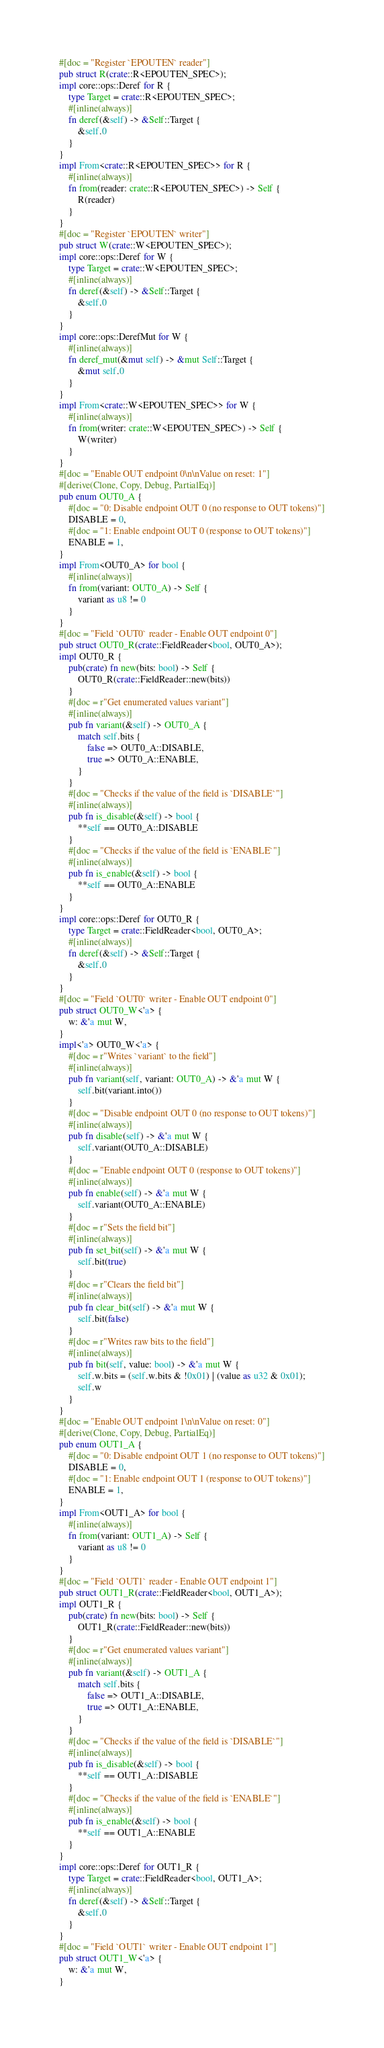Convert code to text. <code><loc_0><loc_0><loc_500><loc_500><_Rust_>#[doc = "Register `EPOUTEN` reader"]
pub struct R(crate::R<EPOUTEN_SPEC>);
impl core::ops::Deref for R {
    type Target = crate::R<EPOUTEN_SPEC>;
    #[inline(always)]
    fn deref(&self) -> &Self::Target {
        &self.0
    }
}
impl From<crate::R<EPOUTEN_SPEC>> for R {
    #[inline(always)]
    fn from(reader: crate::R<EPOUTEN_SPEC>) -> Self {
        R(reader)
    }
}
#[doc = "Register `EPOUTEN` writer"]
pub struct W(crate::W<EPOUTEN_SPEC>);
impl core::ops::Deref for W {
    type Target = crate::W<EPOUTEN_SPEC>;
    #[inline(always)]
    fn deref(&self) -> &Self::Target {
        &self.0
    }
}
impl core::ops::DerefMut for W {
    #[inline(always)]
    fn deref_mut(&mut self) -> &mut Self::Target {
        &mut self.0
    }
}
impl From<crate::W<EPOUTEN_SPEC>> for W {
    #[inline(always)]
    fn from(writer: crate::W<EPOUTEN_SPEC>) -> Self {
        W(writer)
    }
}
#[doc = "Enable OUT endpoint 0\n\nValue on reset: 1"]
#[derive(Clone, Copy, Debug, PartialEq)]
pub enum OUT0_A {
    #[doc = "0: Disable endpoint OUT 0 (no response to OUT tokens)"]
    DISABLE = 0,
    #[doc = "1: Enable endpoint OUT 0 (response to OUT tokens)"]
    ENABLE = 1,
}
impl From<OUT0_A> for bool {
    #[inline(always)]
    fn from(variant: OUT0_A) -> Self {
        variant as u8 != 0
    }
}
#[doc = "Field `OUT0` reader - Enable OUT endpoint 0"]
pub struct OUT0_R(crate::FieldReader<bool, OUT0_A>);
impl OUT0_R {
    pub(crate) fn new(bits: bool) -> Self {
        OUT0_R(crate::FieldReader::new(bits))
    }
    #[doc = r"Get enumerated values variant"]
    #[inline(always)]
    pub fn variant(&self) -> OUT0_A {
        match self.bits {
            false => OUT0_A::DISABLE,
            true => OUT0_A::ENABLE,
        }
    }
    #[doc = "Checks if the value of the field is `DISABLE`"]
    #[inline(always)]
    pub fn is_disable(&self) -> bool {
        **self == OUT0_A::DISABLE
    }
    #[doc = "Checks if the value of the field is `ENABLE`"]
    #[inline(always)]
    pub fn is_enable(&self) -> bool {
        **self == OUT0_A::ENABLE
    }
}
impl core::ops::Deref for OUT0_R {
    type Target = crate::FieldReader<bool, OUT0_A>;
    #[inline(always)]
    fn deref(&self) -> &Self::Target {
        &self.0
    }
}
#[doc = "Field `OUT0` writer - Enable OUT endpoint 0"]
pub struct OUT0_W<'a> {
    w: &'a mut W,
}
impl<'a> OUT0_W<'a> {
    #[doc = r"Writes `variant` to the field"]
    #[inline(always)]
    pub fn variant(self, variant: OUT0_A) -> &'a mut W {
        self.bit(variant.into())
    }
    #[doc = "Disable endpoint OUT 0 (no response to OUT tokens)"]
    #[inline(always)]
    pub fn disable(self) -> &'a mut W {
        self.variant(OUT0_A::DISABLE)
    }
    #[doc = "Enable endpoint OUT 0 (response to OUT tokens)"]
    #[inline(always)]
    pub fn enable(self) -> &'a mut W {
        self.variant(OUT0_A::ENABLE)
    }
    #[doc = r"Sets the field bit"]
    #[inline(always)]
    pub fn set_bit(self) -> &'a mut W {
        self.bit(true)
    }
    #[doc = r"Clears the field bit"]
    #[inline(always)]
    pub fn clear_bit(self) -> &'a mut W {
        self.bit(false)
    }
    #[doc = r"Writes raw bits to the field"]
    #[inline(always)]
    pub fn bit(self, value: bool) -> &'a mut W {
        self.w.bits = (self.w.bits & !0x01) | (value as u32 & 0x01);
        self.w
    }
}
#[doc = "Enable OUT endpoint 1\n\nValue on reset: 0"]
#[derive(Clone, Copy, Debug, PartialEq)]
pub enum OUT1_A {
    #[doc = "0: Disable endpoint OUT 1 (no response to OUT tokens)"]
    DISABLE = 0,
    #[doc = "1: Enable endpoint OUT 1 (response to OUT tokens)"]
    ENABLE = 1,
}
impl From<OUT1_A> for bool {
    #[inline(always)]
    fn from(variant: OUT1_A) -> Self {
        variant as u8 != 0
    }
}
#[doc = "Field `OUT1` reader - Enable OUT endpoint 1"]
pub struct OUT1_R(crate::FieldReader<bool, OUT1_A>);
impl OUT1_R {
    pub(crate) fn new(bits: bool) -> Self {
        OUT1_R(crate::FieldReader::new(bits))
    }
    #[doc = r"Get enumerated values variant"]
    #[inline(always)]
    pub fn variant(&self) -> OUT1_A {
        match self.bits {
            false => OUT1_A::DISABLE,
            true => OUT1_A::ENABLE,
        }
    }
    #[doc = "Checks if the value of the field is `DISABLE`"]
    #[inline(always)]
    pub fn is_disable(&self) -> bool {
        **self == OUT1_A::DISABLE
    }
    #[doc = "Checks if the value of the field is `ENABLE`"]
    #[inline(always)]
    pub fn is_enable(&self) -> bool {
        **self == OUT1_A::ENABLE
    }
}
impl core::ops::Deref for OUT1_R {
    type Target = crate::FieldReader<bool, OUT1_A>;
    #[inline(always)]
    fn deref(&self) -> &Self::Target {
        &self.0
    }
}
#[doc = "Field `OUT1` writer - Enable OUT endpoint 1"]
pub struct OUT1_W<'a> {
    w: &'a mut W,
}</code> 